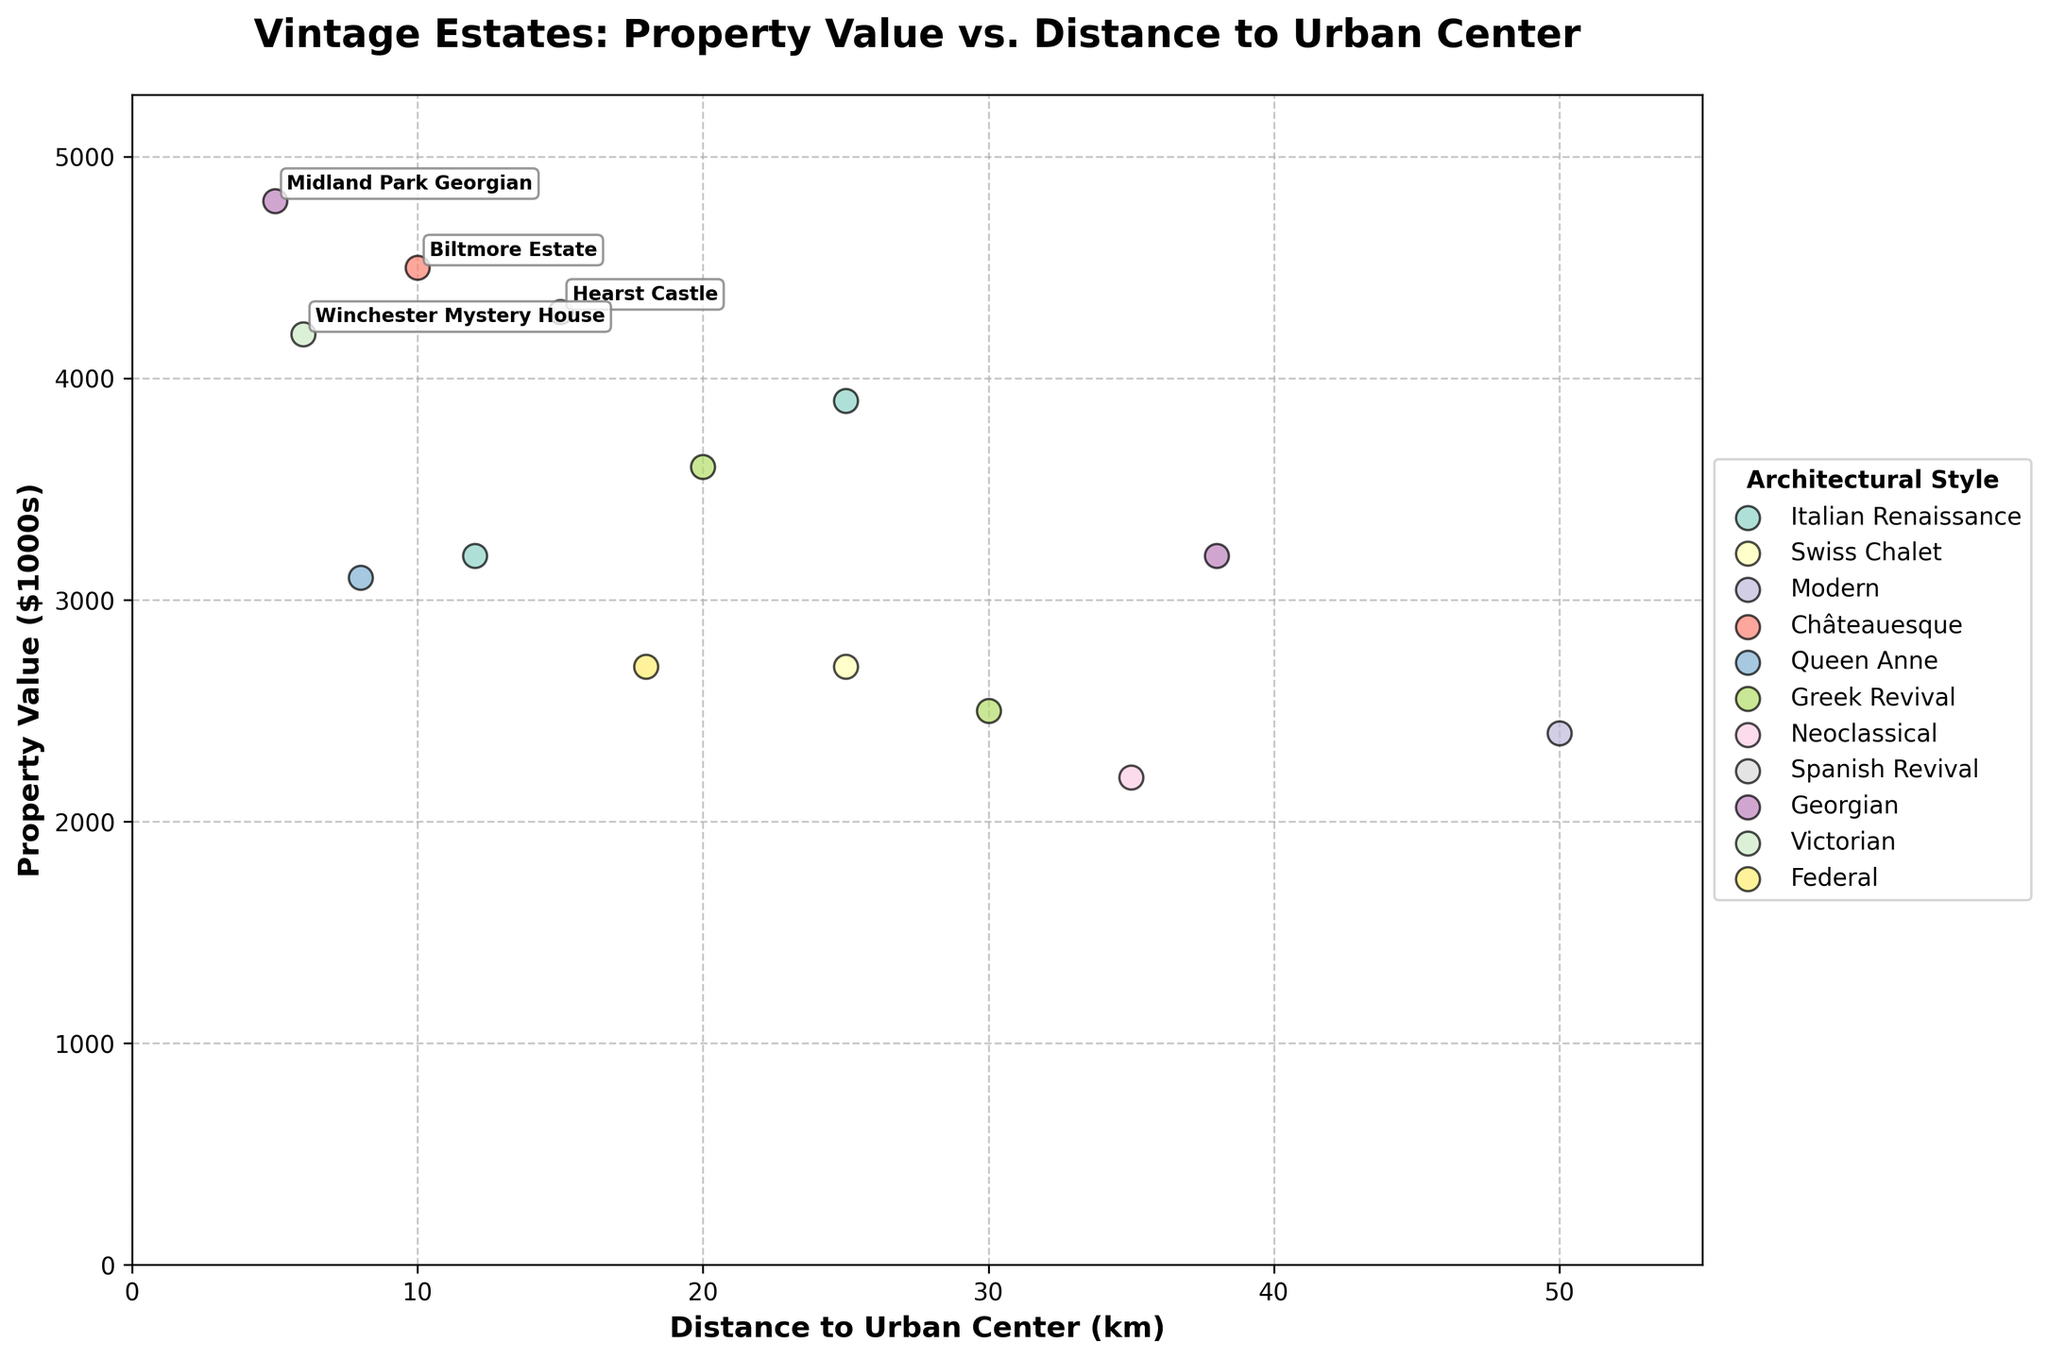What's the title of the plot? The title of the plot is given at the top and reads "Vintage Estates: Property Value vs. Distance to Urban Center".
Answer: Vintage Estates: Property Value vs. Distance to Urban Center How many architectural styles are represented in the plot? Each unique color represents a different architectural style. Counting the different colors shown in the legend next to each style name gives us the number of architectural styles represented.
Answer: 8 Which estate has the highest property value and what style does it belong to? The estate with the highest property value is the one with the tallest scatter point on the vertical axis. From the annotations, we can see that Midland Park Georgian, with a property value of 4800, is the highest. It belongs to the Georgian style.
Answer: Midland Park Georgian, Georgian Which architectural style shows the greatest spread in property values based on distances to urban centers? By observing the vertical spread of scatter points for each color corresponding to an architectural style, we can see which has the widest range of property values. The Italian Renaissance style, marked by its unique color, shows wide variations in property values relative to other styles.
Answer: Italian Renaissance Between Hearst Castle and Biltmore Estate, which one is closer to an urban center and which one has a higher property value? Identify both estates in the plot by their annotations. Then, compare their horizontal positions (distance to urban center) and vertical positions (property value). Biltmore Estate is closer with 10 km whereas Hearst Castle has a higher property value of 4300 against Biltmore's 4500.
Answer: Biltmore Estate is closer; Hearst Castle has a higher value What is the average property value of estates in the Neoclassical and Modern styles combined? First, list the property values for Neoclassical (2200) and Modern (2400) styles. Then, sum these values and divide by the number of estates (2). (2200 + 2400) / 2 = 4600 / 2 = 2300.
Answer: 2300 Which estate has the shortest distance to an urban center in a style other than Georgian, and what is this distance? Exclude the Georgian styles, then identify the estate with the smallest value on the horizontal axis. Winchester Mystery House has the shortest distance of 6 km and is of Victorian style.
Answer: Winchester Mystery House, 6 km Are there any architectural styles where all estates lie within 20 km of an urban center? Look for any color group in the legend where all corresponding scatter points are positioned at or under the 20 km mark on the horizontal axis. The Queen Anne (Glenview Mansion, 8 km) satisfies this condition.
Answer: Queen Anne For the Federal style, what is the property value, and how far is it from an urban center? Find the scatter point associated with the Federal style by its corresponding color and reference its position against the axes. Belle Grove Plantation at 2700 with a distance of 18 km fits this style.
Answer: 2700, 18 km 